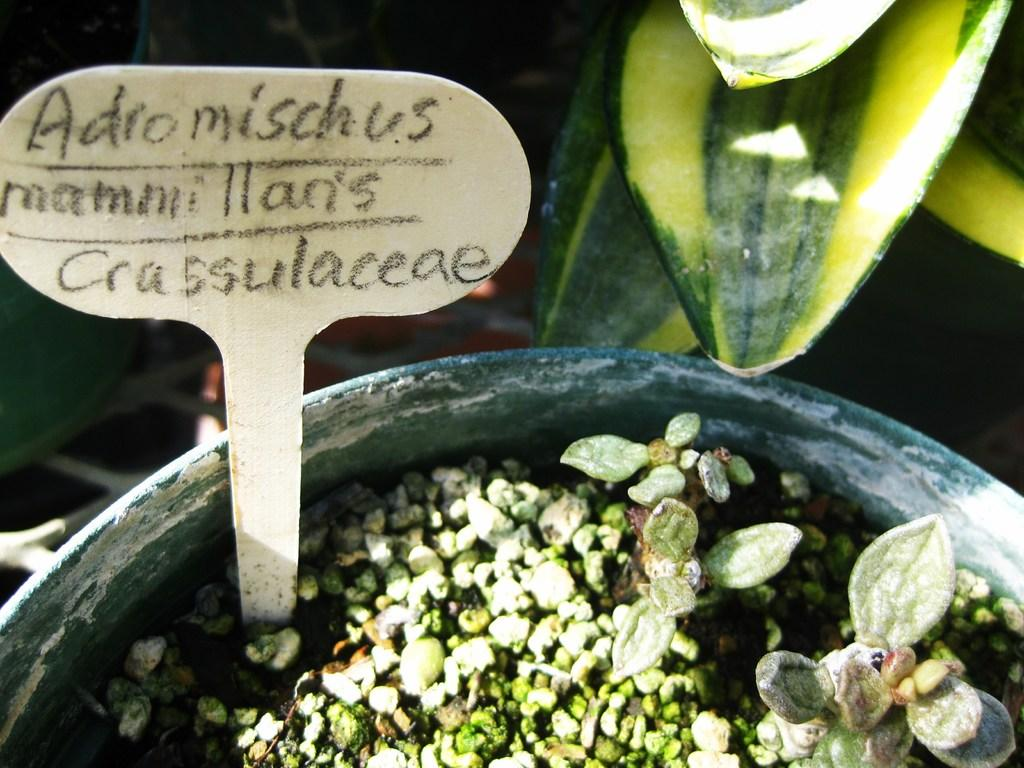What celestial bodies are depicted in the image? There are planets in the image. What is the board placed in? The board is in a pot in the image. What is written on the board? There are words on the board. What type of vegetation can be seen in the background of the image? There are leaves in the background of the image. What type of chain can be seen connecting the planets in the image? There is no chain connecting the planets in the image. 